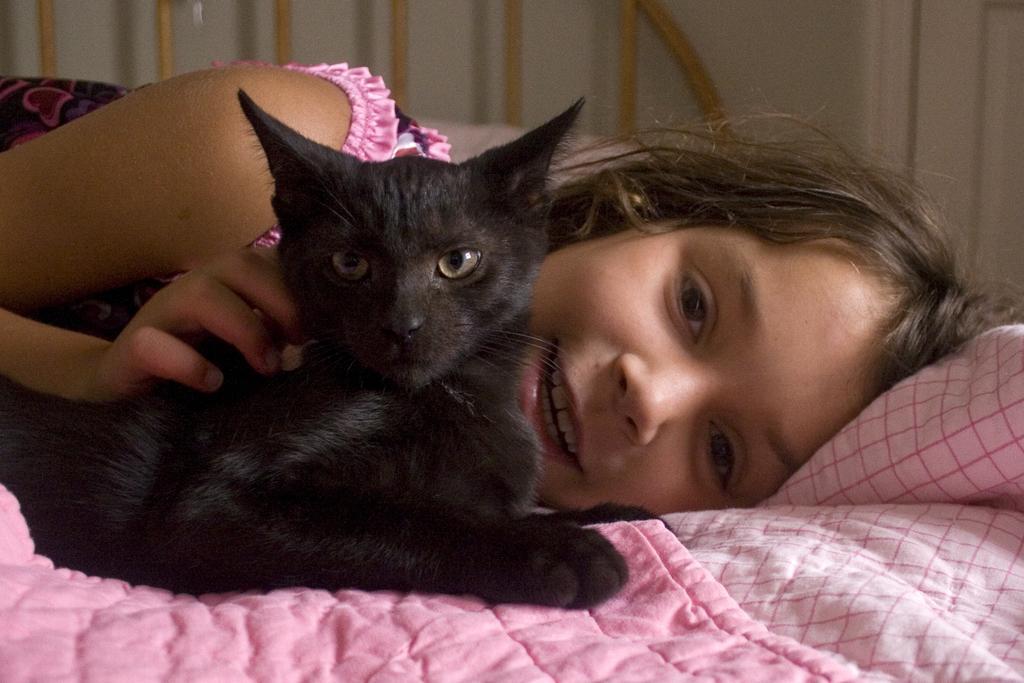Could you give a brief overview of what you see in this image? This image consist of a cat and a girl. The cat is in black color. Both are sleeping on the bed. The girl is wearing pink dress. In the background, there is a wall. The pillow and bed sheet are in pink color. 